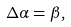Convert formula to latex. <formula><loc_0><loc_0><loc_500><loc_500>\Delta \alpha = \beta ,</formula> 